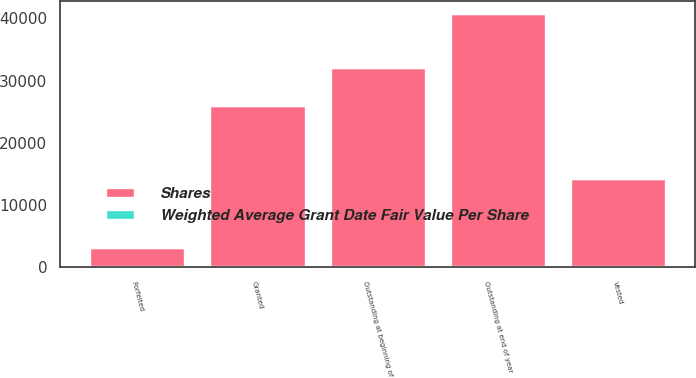<chart> <loc_0><loc_0><loc_500><loc_500><stacked_bar_chart><ecel><fcel>Outstanding at beginning of<fcel>Granted<fcel>Vested<fcel>Forfeited<fcel>Outstanding at end of year<nl><fcel>Shares<fcel>32262<fcel>26036<fcel>14253<fcel>3237<fcel>40808<nl><fcel>Weighted Average Grant Date Fair Value Per Share<fcel>21<fcel>28<fcel>24<fcel>22<fcel>24<nl></chart> 